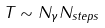<formula> <loc_0><loc_0><loc_500><loc_500>T \sim N _ { \gamma } N _ { s t e p s }</formula> 